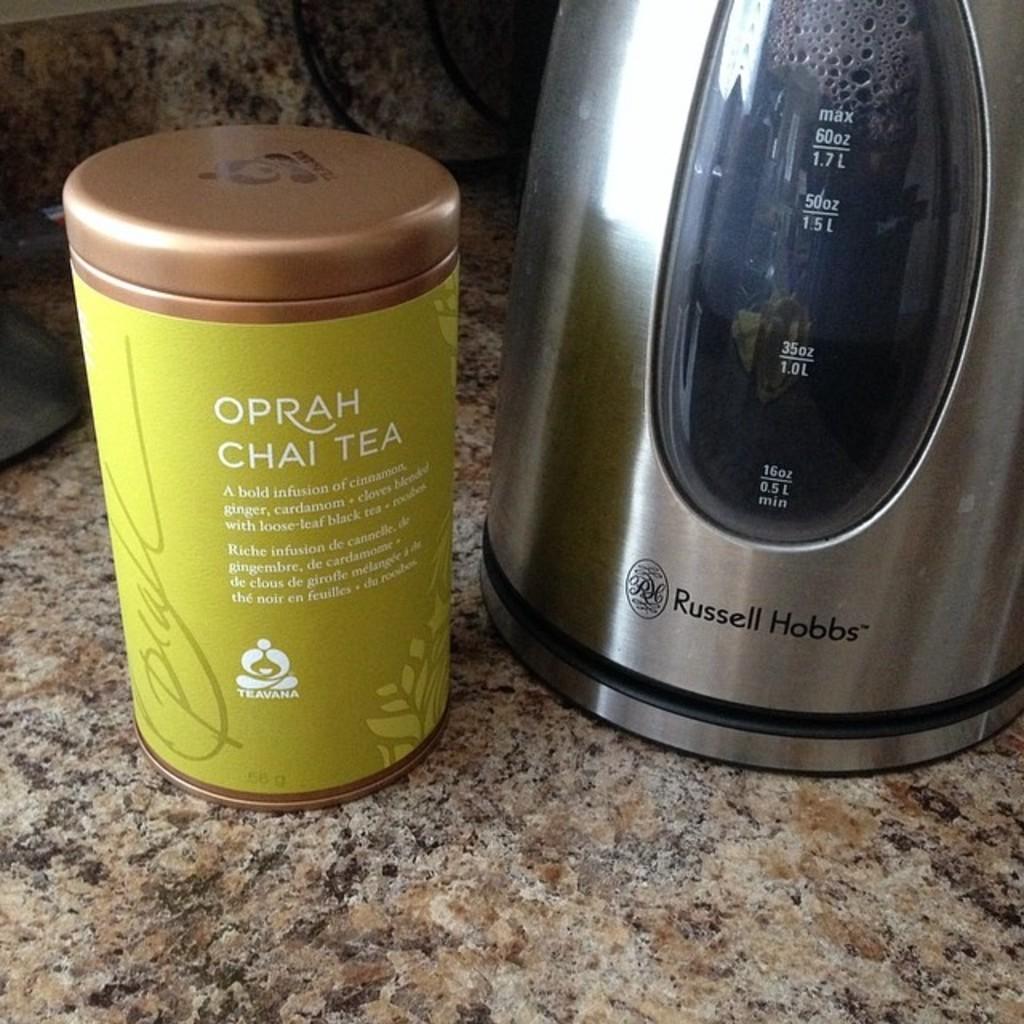What is the name of the famous celebrity on the can of tea?
Make the answer very short. Oprah. 